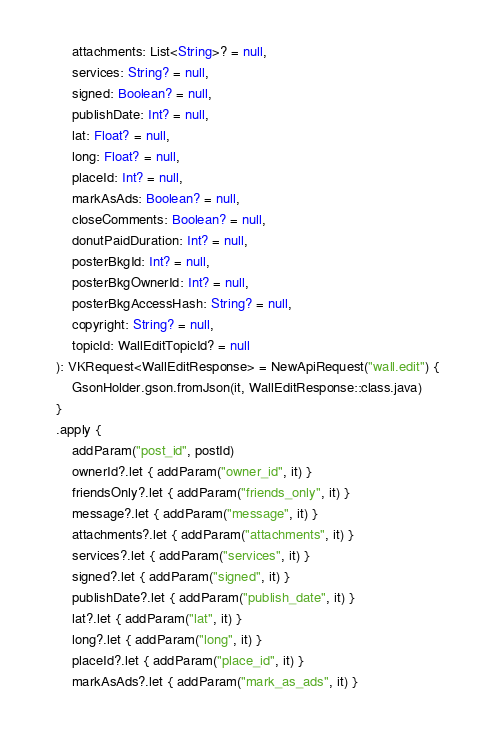Convert code to text. <code><loc_0><loc_0><loc_500><loc_500><_Kotlin_>        attachments: List<String>? = null,
        services: String? = null,
        signed: Boolean? = null,
        publishDate: Int? = null,
        lat: Float? = null,
        long: Float? = null,
        placeId: Int? = null,
        markAsAds: Boolean? = null,
        closeComments: Boolean? = null,
        donutPaidDuration: Int? = null,
        posterBkgId: Int? = null,
        posterBkgOwnerId: Int? = null,
        posterBkgAccessHash: String? = null,
        copyright: String? = null,
        topicId: WallEditTopicId? = null
    ): VKRequest<WallEditResponse> = NewApiRequest("wall.edit") {
        GsonHolder.gson.fromJson(it, WallEditResponse::class.java)
    }
    .apply {
        addParam("post_id", postId)
        ownerId?.let { addParam("owner_id", it) }
        friendsOnly?.let { addParam("friends_only", it) }
        message?.let { addParam("message", it) }
        attachments?.let { addParam("attachments", it) }
        services?.let { addParam("services", it) }
        signed?.let { addParam("signed", it) }
        publishDate?.let { addParam("publish_date", it) }
        lat?.let { addParam("lat", it) }
        long?.let { addParam("long", it) }
        placeId?.let { addParam("place_id", it) }
        markAsAds?.let { addParam("mark_as_ads", it) }</code> 